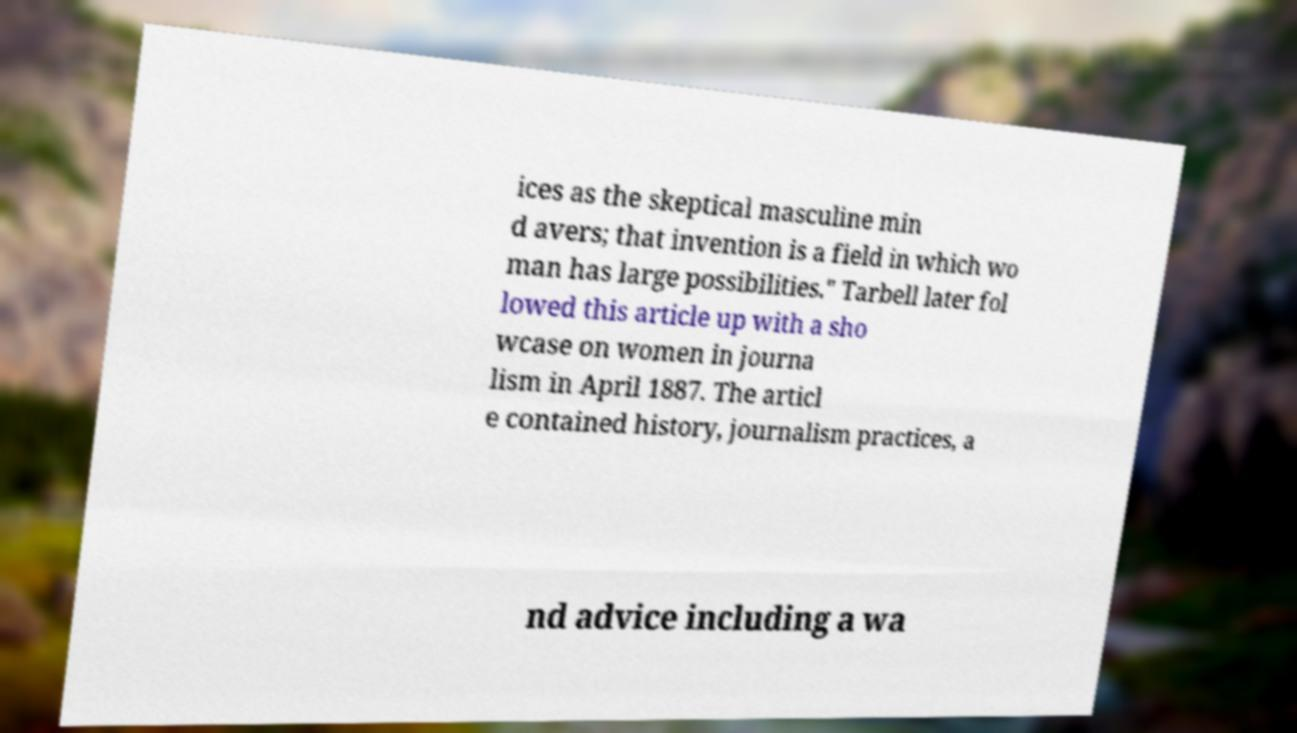Please read and relay the text visible in this image. What does it say? ices as the skeptical masculine min d avers; that invention is a field in which wo man has large possibilities." Tarbell later fol lowed this article up with a sho wcase on women in journa lism in April 1887. The articl e contained history, journalism practices, a nd advice including a wa 